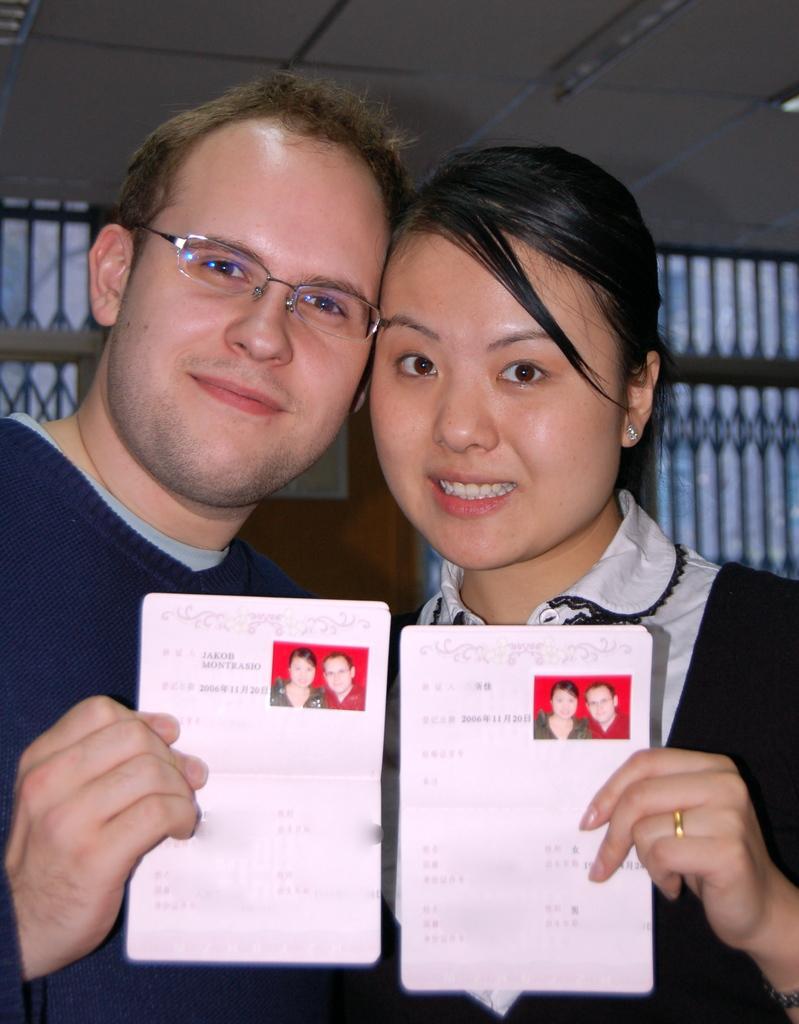In one or two sentences, can you explain what this image depicts? In the middle of the image two persons are standing and smiling and holding some papers. Behind them there is wall. At the top of the image there is ceiling. 